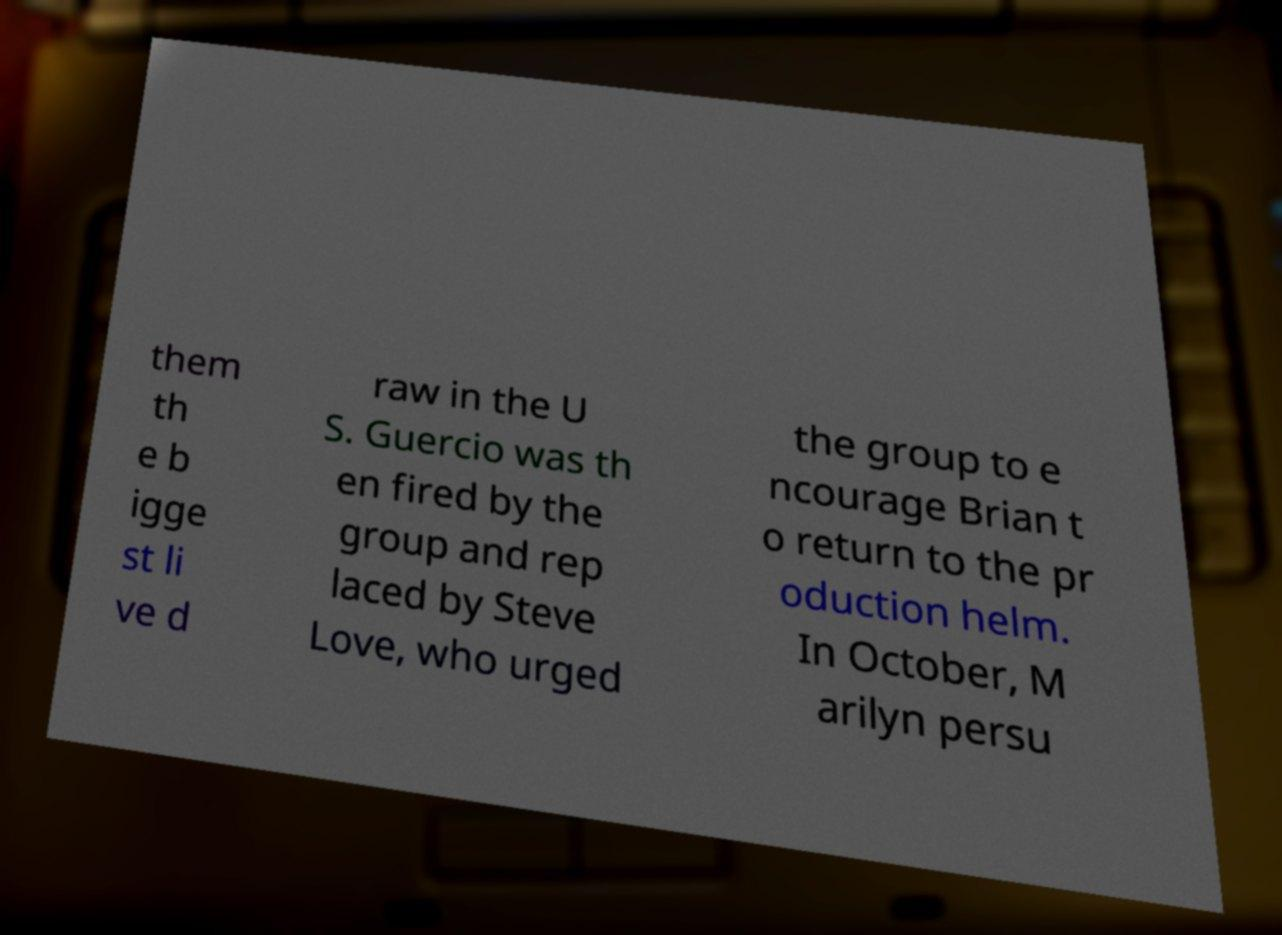Can you read and provide the text displayed in the image?This photo seems to have some interesting text. Can you extract and type it out for me? them th e b igge st li ve d raw in the U S. Guercio was th en fired by the group and rep laced by Steve Love, who urged the group to e ncourage Brian t o return to the pr oduction helm. In October, M arilyn persu 